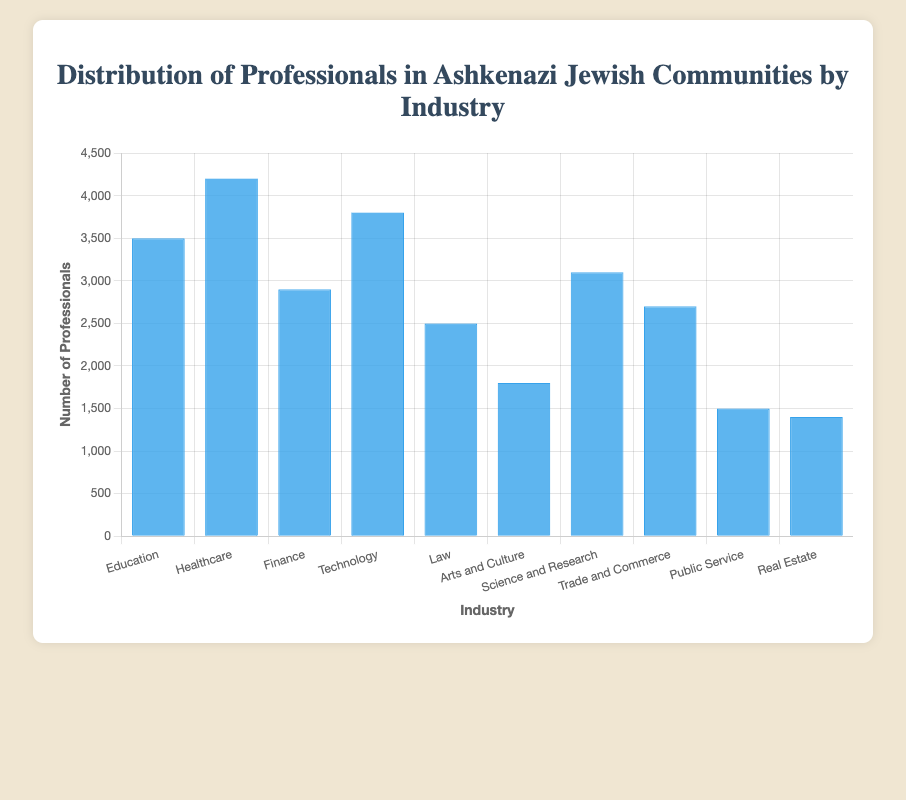Which industry has the highest number of professionals? The figure shows different industries with labeled bars representing the number of professionals. The tallest bar corresponds to the "Healthcare" industry.
Answer: Healthcare Which industry has the lowest number of professionals? By observing the shortest bar, we see that the "Real Estate" industry has the lowest number of professionals.
Answer: Real Estate What is the total number of professionals in the "Education" and "Finance" industries combined? The figure shows "Education" with 3500 professionals and "Finance" with 2900 professionals. Adding these numbers together: 3500 + 2900 = 6400.
Answer: 6400 Which industry has more professionals: "Law" or "Trade and Commerce"? Comparing the heights of the bars, "Trade and Commerce" (2700) is taller than "Law" (2500).
Answer: Trade and Commerce What is the median number of professionals across all industries? First, we list the number of professionals for each industry in ascending order: 1400, 1500, 1800, 2500, 2700, 2900, 3100, 3500, 3800, 4200. The median is the middle number, which is the 5th and 6th values averaged (2700 + 2900)/2 = 2800.
Answer: 2800 How many industries have more than 3000 professionals? By counting bars taller than 3000, we identify "Education," "Healthcare," "Technology," and "Science and Research," making a total of 4 industries.
Answer: 4 Which industry has the second fewest professionals? By identifying the second shortest bar, we find that "Public Service" with 1500 professionals is the second fewest.
Answer: Public Service How many more professionals are there in "Technology" compared to "Arts and Culture"? Subtracting the number of professionals in "Arts and Culture" (1800) from "Technology" (3800): 3800 - 1800 = 2000.
Answer: 2000 Are there more professionals in "Healthcare" than in "Science and Research" and "Law" combined? First, sum the professionals in "Science and Research" (3100) and "Law" (2500): 3100 + 2500 = 5600. "Healthcare" has 4200 professionals, which is less than 5600.
Answer: No What is the average number of professionals across all industries? The total number of professionals is calculated by summing all the values: 3500 + 4200 + 2900 + 3800 + 2500 + 1800 + 3100 + 2700 + 1500 + 1400 = 27400. Dividing by the number of industries (10): 27400 / 10 = 2740.
Answer: 2740 